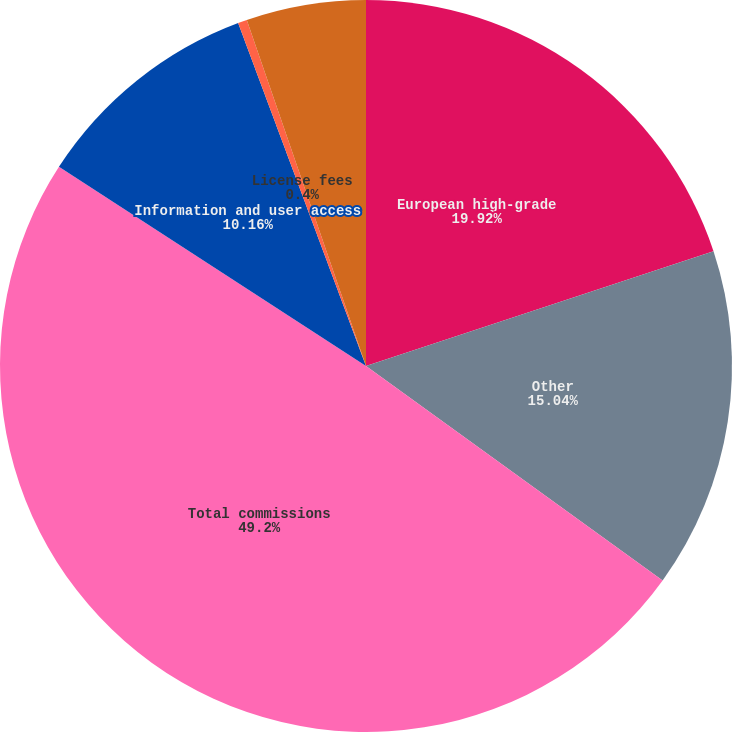<chart> <loc_0><loc_0><loc_500><loc_500><pie_chart><fcel>European high-grade<fcel>Other<fcel>Total commissions<fcel>Information and user access<fcel>License fees<fcel>Investment income<nl><fcel>19.92%<fcel>15.04%<fcel>49.2%<fcel>10.16%<fcel>0.4%<fcel>5.28%<nl></chart> 